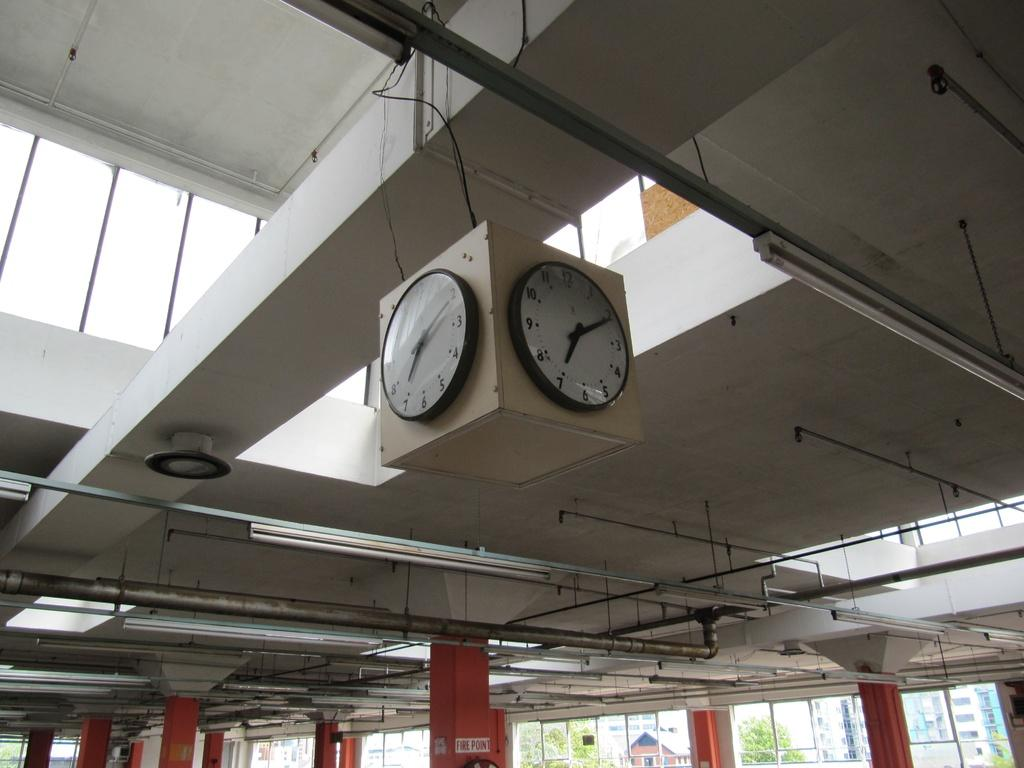<image>
Share a concise interpretation of the image provided. An orange column is labelled "Fire Point," below a clock hanging from a vent. 